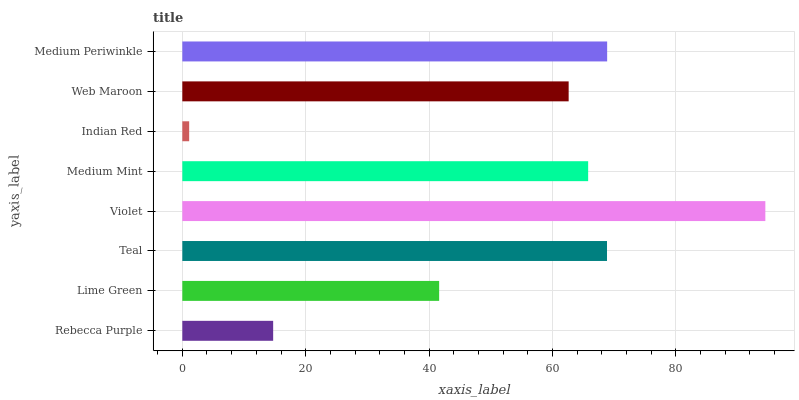Is Indian Red the minimum?
Answer yes or no. Yes. Is Violet the maximum?
Answer yes or no. Yes. Is Lime Green the minimum?
Answer yes or no. No. Is Lime Green the maximum?
Answer yes or no. No. Is Lime Green greater than Rebecca Purple?
Answer yes or no. Yes. Is Rebecca Purple less than Lime Green?
Answer yes or no. Yes. Is Rebecca Purple greater than Lime Green?
Answer yes or no. No. Is Lime Green less than Rebecca Purple?
Answer yes or no. No. Is Medium Mint the high median?
Answer yes or no. Yes. Is Web Maroon the low median?
Answer yes or no. Yes. Is Indian Red the high median?
Answer yes or no. No. Is Teal the low median?
Answer yes or no. No. 